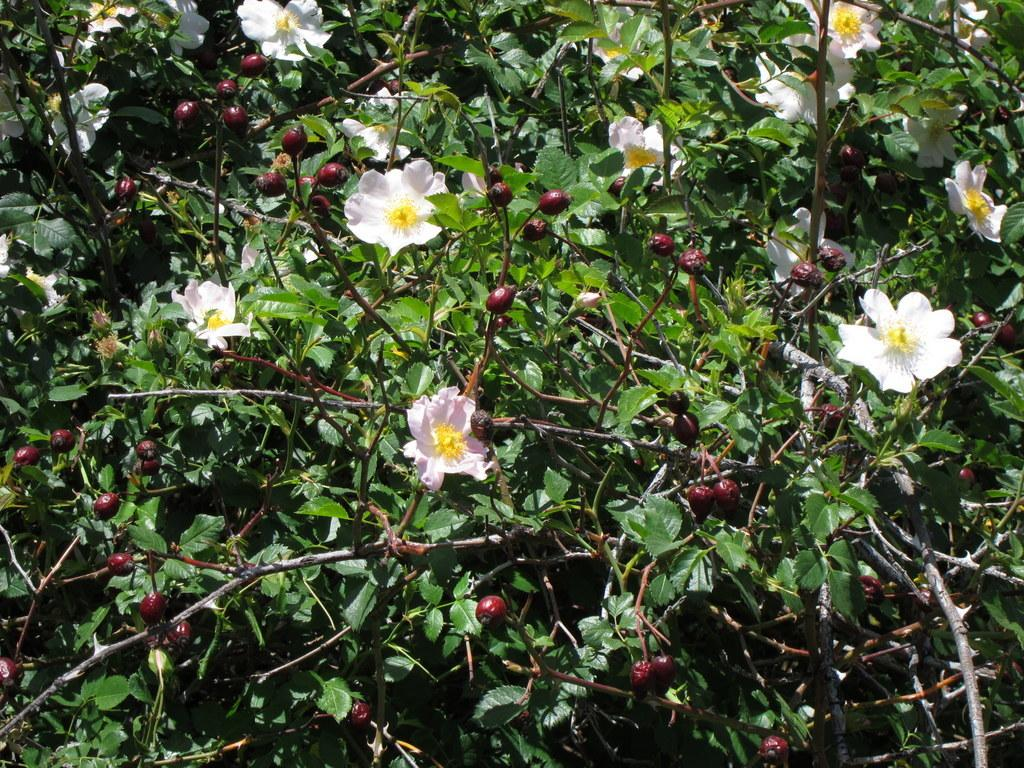What is the main subject of the image? The main subject of the image is plants. Can you describe the plants in the image? The plants in the image have flowers and fruits. What country is the voice of the plant from in the image? There is no voice present in the image, as plants do not have the ability to speak. 